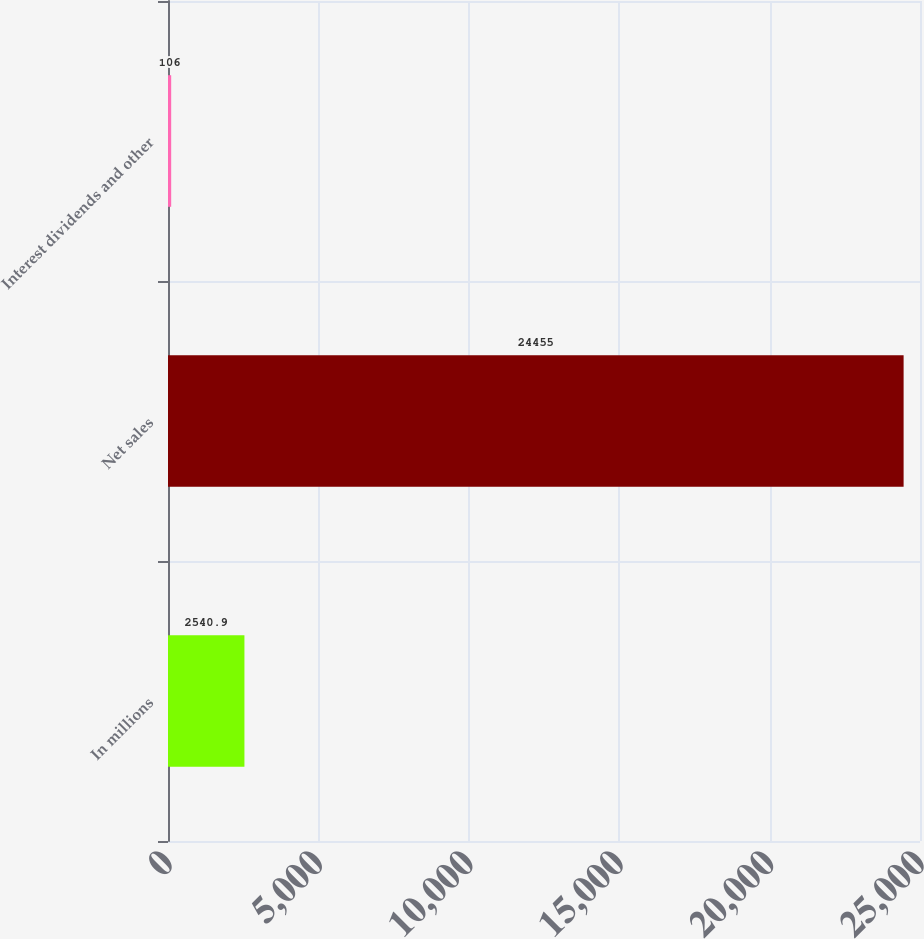Convert chart to OTSL. <chart><loc_0><loc_0><loc_500><loc_500><bar_chart><fcel>In millions<fcel>Net sales<fcel>Interest dividends and other<nl><fcel>2540.9<fcel>24455<fcel>106<nl></chart> 